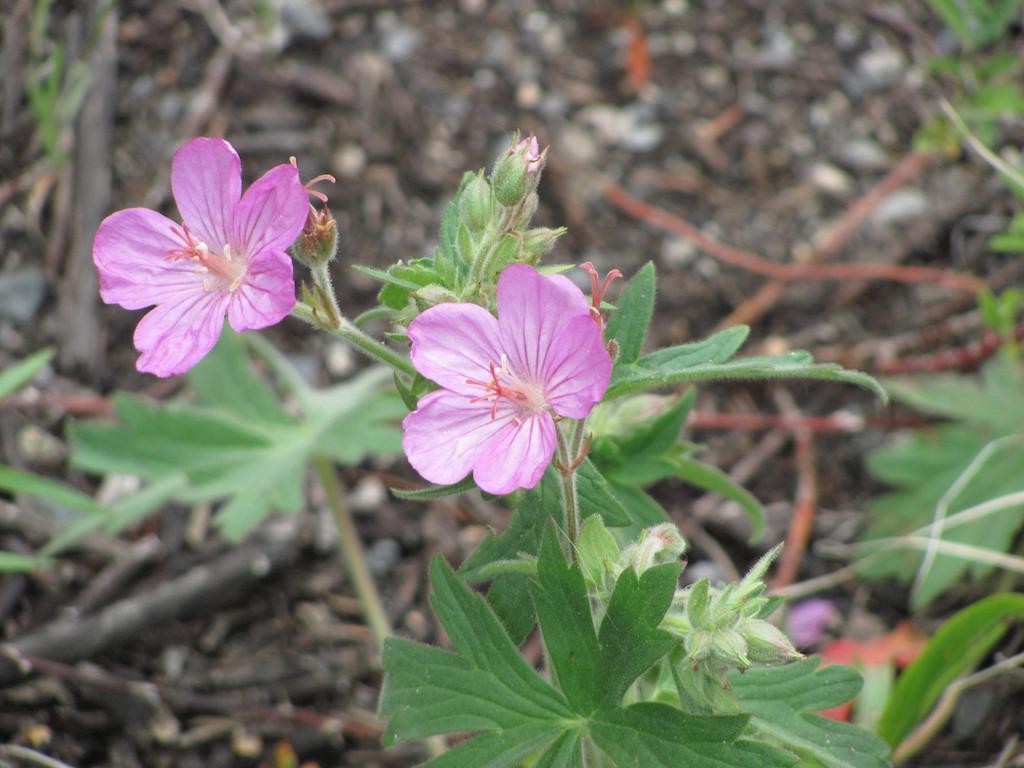Could you give a brief overview of what you see in this image? In the foreground of this image, there are two pink flowers to the plant and also buds to it. In the background, there is the ground and few more plants. 